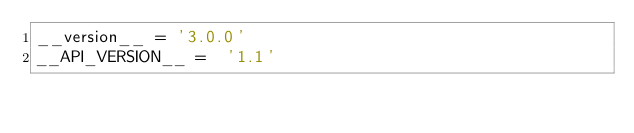<code> <loc_0><loc_0><loc_500><loc_500><_Python_>__version__ = '3.0.0'
__API_VERSION__ =  '1.1'
</code> 